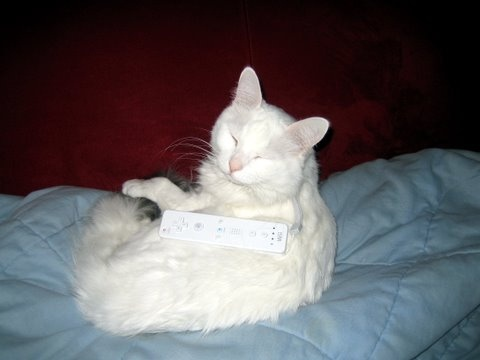Describe the objects in this image and their specific colors. I can see cat in black, lightgray, darkgray, and gray tones and remote in black, white, darkgray, and lightgray tones in this image. 